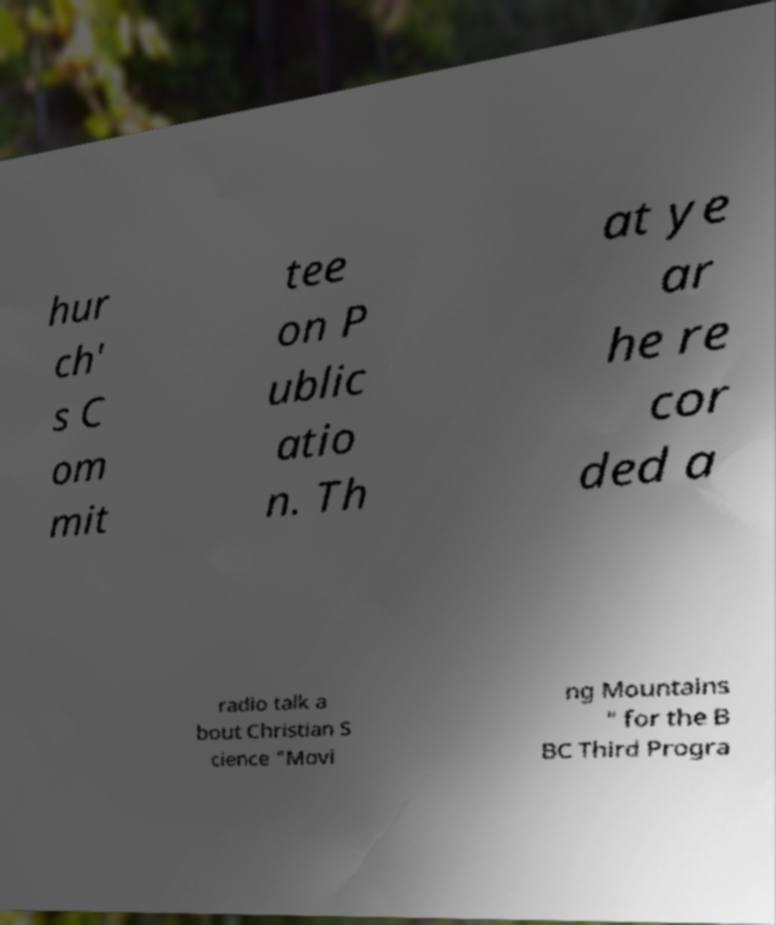Please read and relay the text visible in this image. What does it say? hur ch' s C om mit tee on P ublic atio n. Th at ye ar he re cor ded a radio talk a bout Christian S cience "Movi ng Mountains " for the B BC Third Progra 